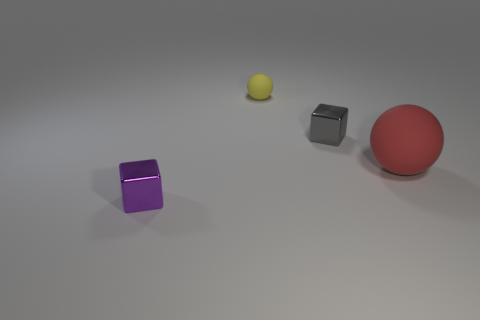Add 1 matte spheres. How many objects exist? 5 Add 1 red rubber objects. How many red rubber objects exist? 2 Subtract 1 purple blocks. How many objects are left? 3 Subtract all tiny purple things. Subtract all big green metal cylinders. How many objects are left? 3 Add 3 yellow rubber spheres. How many yellow rubber spheres are left? 4 